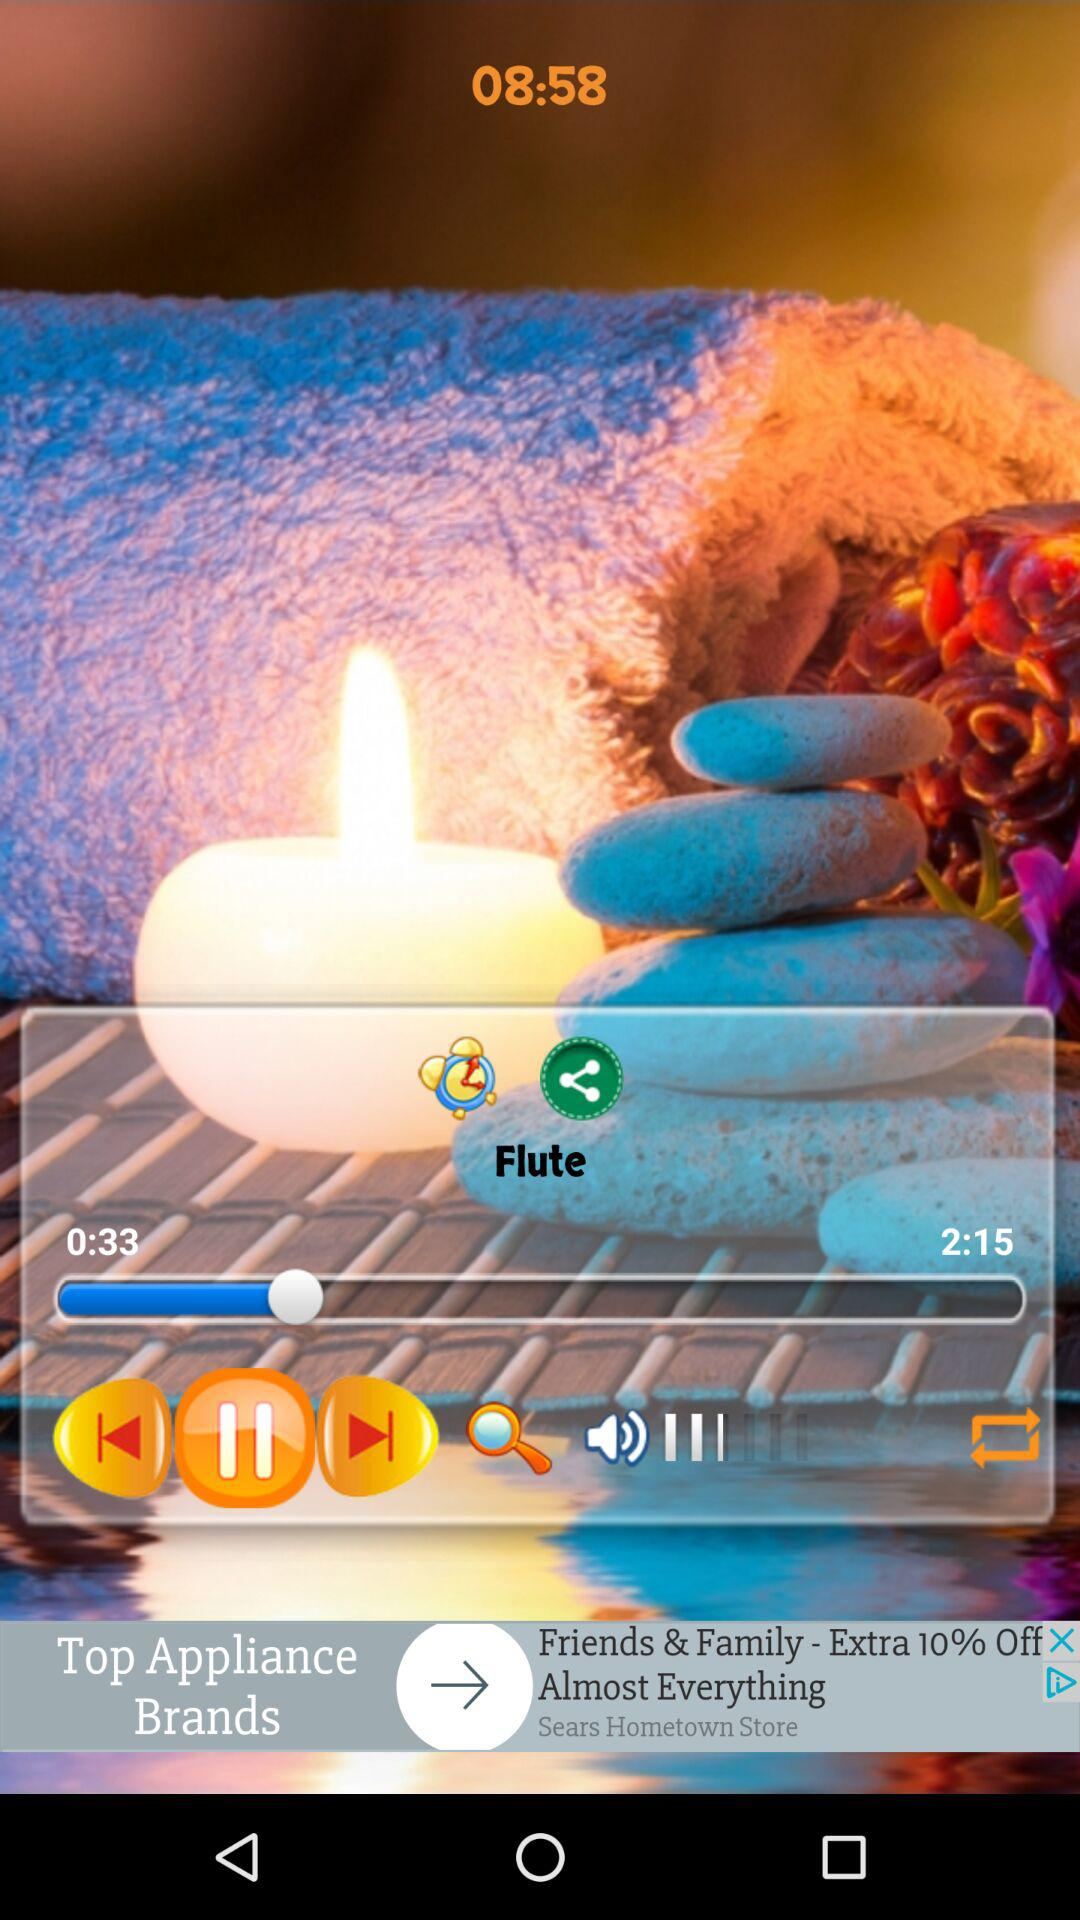What is the name of the audio currently playing? The name of the audio is "Flute". 